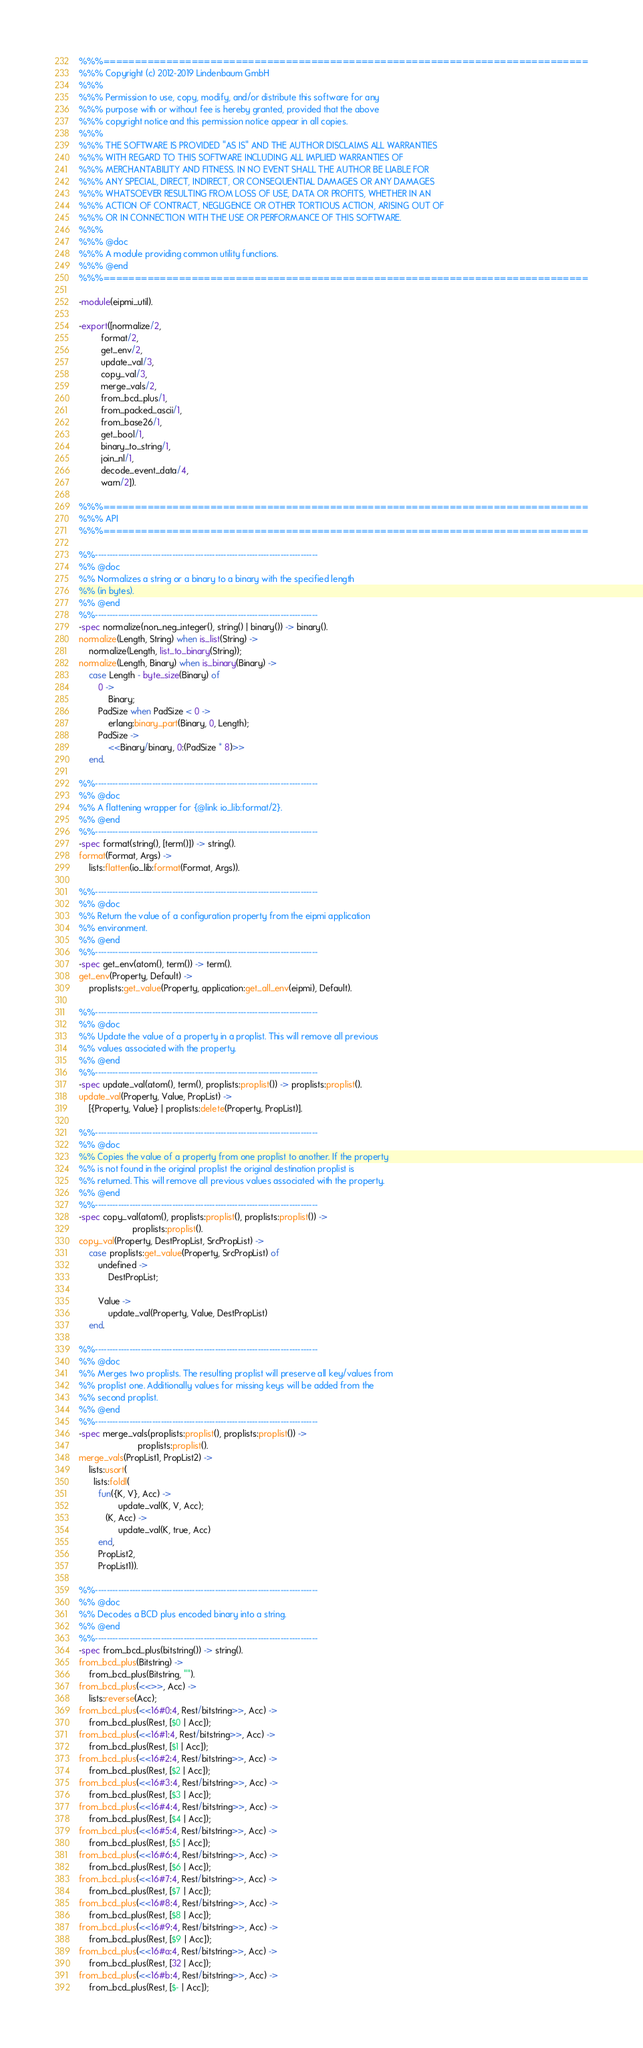<code> <loc_0><loc_0><loc_500><loc_500><_Erlang_>%%%=============================================================================
%%% Copyright (c) 2012-2019 Lindenbaum GmbH
%%%
%%% Permission to use, copy, modify, and/or distribute this software for any
%%% purpose with or without fee is hereby granted, provided that the above
%%% copyright notice and this permission notice appear in all copies.
%%%
%%% THE SOFTWARE IS PROVIDED "AS IS" AND THE AUTHOR DISCLAIMS ALL WARRANTIES
%%% WITH REGARD TO THIS SOFTWARE INCLUDING ALL IMPLIED WARRANTIES OF
%%% MERCHANTABILITY AND FITNESS. IN NO EVENT SHALL THE AUTHOR BE LIABLE FOR
%%% ANY SPECIAL, DIRECT, INDIRECT, OR CONSEQUENTIAL DAMAGES OR ANY DAMAGES
%%% WHATSOEVER RESULTING FROM LOSS OF USE, DATA OR PROFITS, WHETHER IN AN
%%% ACTION OF CONTRACT, NEGLIGENCE OR OTHER TORTIOUS ACTION, ARISING OUT OF
%%% OR IN CONNECTION WITH THE USE OR PERFORMANCE OF THIS SOFTWARE.
%%%
%%% @doc
%%% A module providing common utility functions.
%%% @end
%%%=============================================================================

-module(eipmi_util).

-export([normalize/2,
         format/2,
         get_env/2,
         update_val/3,
         copy_val/3,
         merge_vals/2,
         from_bcd_plus/1,
         from_packed_ascii/1,
         from_base26/1,
         get_bool/1,
         binary_to_string/1,
         join_nl/1,
         decode_event_data/4,
         warn/2]).

%%%=============================================================================
%%% API
%%%=============================================================================

%%------------------------------------------------------------------------------
%% @doc
%% Normalizes a string or a binary to a binary with the specified length
%% (in bytes).
%% @end
%%------------------------------------------------------------------------------
-spec normalize(non_neg_integer(), string() | binary()) -> binary().
normalize(Length, String) when is_list(String) ->
    normalize(Length, list_to_binary(String));
normalize(Length, Binary) when is_binary(Binary) ->
    case Length - byte_size(Binary) of
        0 ->
            Binary;
        PadSize when PadSize < 0 ->
            erlang:binary_part(Binary, 0, Length);
        PadSize ->
            <<Binary/binary, 0:(PadSize * 8)>>
    end.

%%------------------------------------------------------------------------------
%% @doc
%% A flattening wrapper for {@link io_lib:format/2}.
%% @end
%%------------------------------------------------------------------------------
-spec format(string(), [term()]) -> string().
format(Format, Args) ->
    lists:flatten(io_lib:format(Format, Args)).

%%------------------------------------------------------------------------------
%% @doc
%% Return the value of a configuration property from the eipmi application
%% environment.
%% @end
%%------------------------------------------------------------------------------
-spec get_env(atom(), term()) -> term().
get_env(Property, Default) ->
    proplists:get_value(Property, application:get_all_env(eipmi), Default).

%%------------------------------------------------------------------------------
%% @doc
%% Update the value of a property in a proplist. This will remove all previous
%% values associated with the property.
%% @end
%%------------------------------------------------------------------------------
-spec update_val(atom(), term(), proplists:proplist()) -> proplists:proplist().
update_val(Property, Value, PropList) ->
    [{Property, Value} | proplists:delete(Property, PropList)].

%%------------------------------------------------------------------------------
%% @doc
%% Copies the value of a property from one proplist to another. If the property
%% is not found in the original proplist the original destination proplist is
%% returned. This will remove all previous values associated with the property.
%% @end
%%------------------------------------------------------------------------------
-spec copy_val(atom(), proplists:proplist(), proplists:proplist()) ->
                      proplists:proplist().
copy_val(Property, DestPropList, SrcPropList) ->
    case proplists:get_value(Property, SrcPropList) of
        undefined ->
            DestPropList;

        Value ->
            update_val(Property, Value, DestPropList)
    end.

%%------------------------------------------------------------------------------
%% @doc
%% Merges two proplists. The resulting proplist will preserve all key/values from
%% proplist one. Additionally values for missing keys will be added from the
%% second proplist.
%% @end
%%------------------------------------------------------------------------------
-spec merge_vals(proplists:proplist(), proplists:proplist()) ->
                        proplists:proplist().
merge_vals(PropList1, PropList2) ->
    lists:usort(
      lists:foldl(
        fun({K, V}, Acc) ->
                update_val(K, V, Acc);
           (K, Acc) ->
                update_val(K, true, Acc)
        end,
        PropList2,
        PropList1)).

%%------------------------------------------------------------------------------
%% @doc
%% Decodes a BCD plus encoded binary into a string.
%% @end
%%------------------------------------------------------------------------------
-spec from_bcd_plus(bitstring()) -> string().
from_bcd_plus(Bitstring) ->
    from_bcd_plus(Bitstring, "").
from_bcd_plus(<<>>, Acc) ->
    lists:reverse(Acc);
from_bcd_plus(<<16#0:4, Rest/bitstring>>, Acc) ->
    from_bcd_plus(Rest, [$0 | Acc]);
from_bcd_plus(<<16#1:4, Rest/bitstring>>, Acc) ->
    from_bcd_plus(Rest, [$1 | Acc]);
from_bcd_plus(<<16#2:4, Rest/bitstring>>, Acc) ->
    from_bcd_plus(Rest, [$2 | Acc]);
from_bcd_plus(<<16#3:4, Rest/bitstring>>, Acc) ->
    from_bcd_plus(Rest, [$3 | Acc]);
from_bcd_plus(<<16#4:4, Rest/bitstring>>, Acc) ->
    from_bcd_plus(Rest, [$4 | Acc]);
from_bcd_plus(<<16#5:4, Rest/bitstring>>, Acc) ->
    from_bcd_plus(Rest, [$5 | Acc]);
from_bcd_plus(<<16#6:4, Rest/bitstring>>, Acc) ->
    from_bcd_plus(Rest, [$6 | Acc]);
from_bcd_plus(<<16#7:4, Rest/bitstring>>, Acc) ->
    from_bcd_plus(Rest, [$7 | Acc]);
from_bcd_plus(<<16#8:4, Rest/bitstring>>, Acc) ->
    from_bcd_plus(Rest, [$8 | Acc]);
from_bcd_plus(<<16#9:4, Rest/bitstring>>, Acc) ->
    from_bcd_plus(Rest, [$9 | Acc]);
from_bcd_plus(<<16#a:4, Rest/bitstring>>, Acc) ->
    from_bcd_plus(Rest, [32 | Acc]);
from_bcd_plus(<<16#b:4, Rest/bitstring>>, Acc) ->
    from_bcd_plus(Rest, [$- | Acc]);</code> 